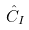<formula> <loc_0><loc_0><loc_500><loc_500>\hat { C } _ { I }</formula> 